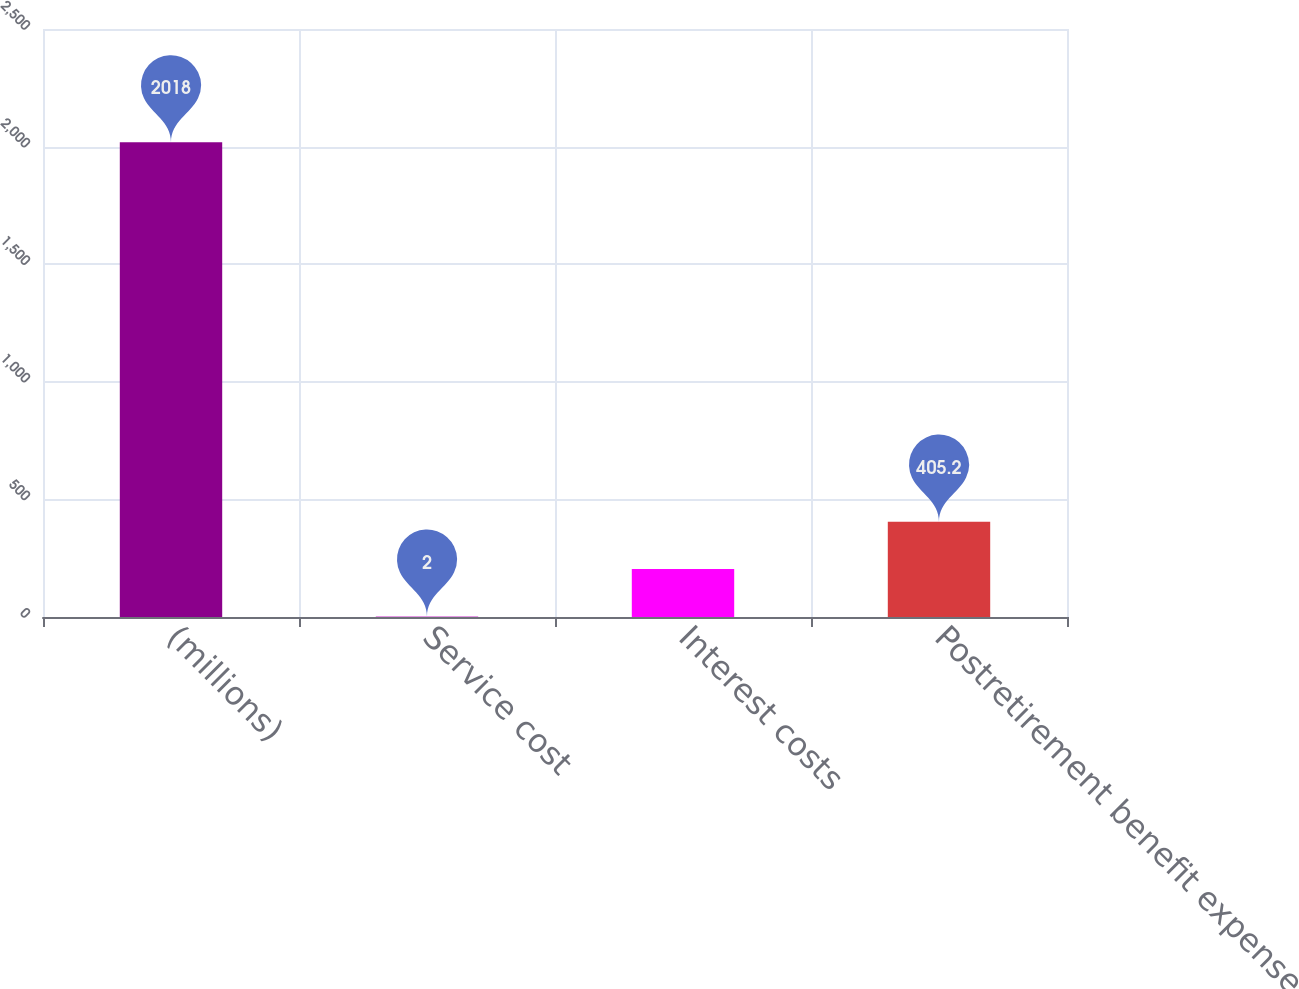<chart> <loc_0><loc_0><loc_500><loc_500><bar_chart><fcel>(millions)<fcel>Service cost<fcel>Interest costs<fcel>Postretirement benefit expense<nl><fcel>2018<fcel>2<fcel>203.6<fcel>405.2<nl></chart> 